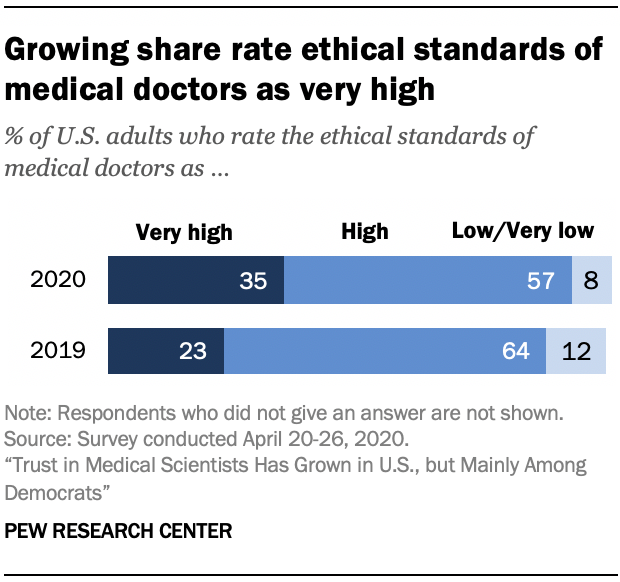Point out several critical features in this image. The ratio of low and very low bars in 2020 was 0.085416667..., which is a decrease from the ratio in 2019. In 2020, the value of the rightmost bar is 8. 